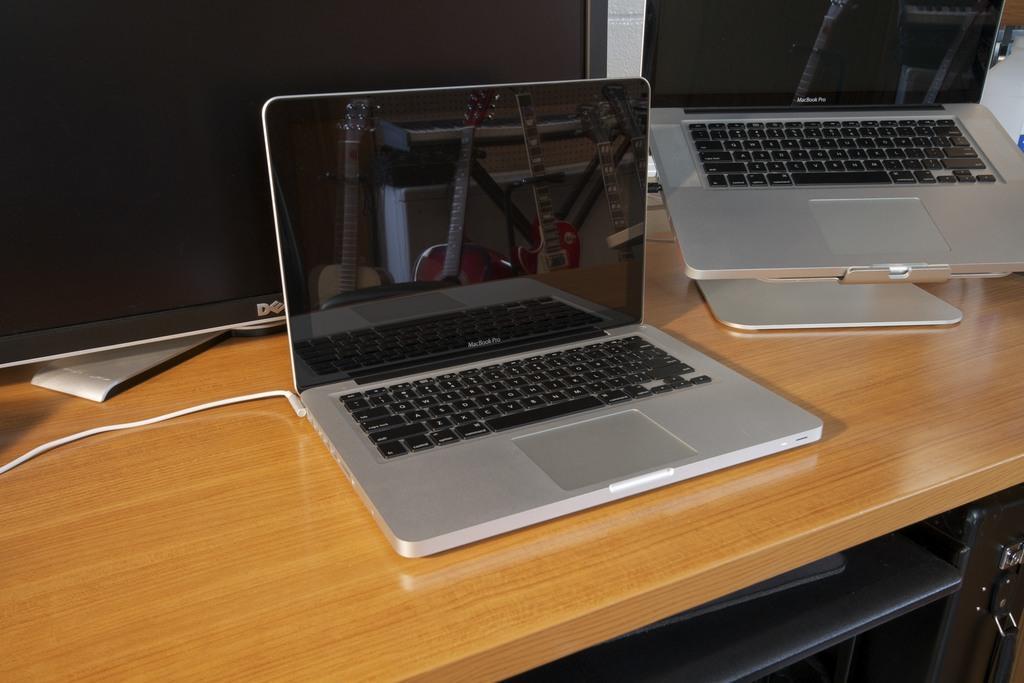In one or two sentences, can you explain what this image depicts? In the image there is a table. On table we can see two laptops and a lcd display. 